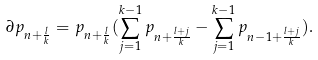<formula> <loc_0><loc_0><loc_500><loc_500>\partial p _ { n + \frac { l } { k } } = p _ { n + \frac { l } { k } } ( \sum _ { j = 1 } ^ { k - 1 } p _ { n + \frac { l + j } { k } } - \sum _ { j = 1 } ^ { k - 1 } p _ { n - 1 + \frac { l + j } { k } } ) .</formula> 